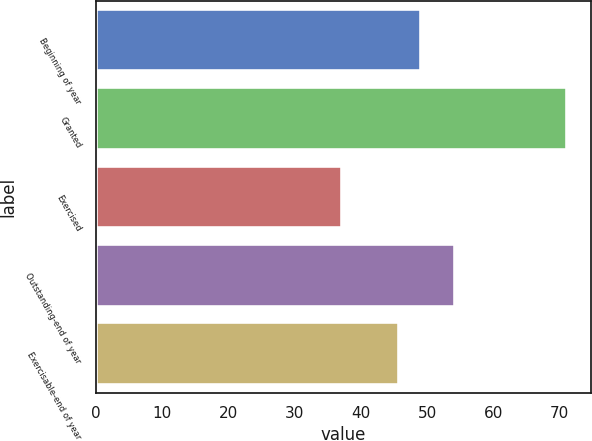Convert chart to OTSL. <chart><loc_0><loc_0><loc_500><loc_500><bar_chart><fcel>Beginning of year<fcel>Granted<fcel>Exercised<fcel>Outstanding-end of year<fcel>Exercisable-end of year<nl><fcel>49.1<fcel>71.12<fcel>37.19<fcel>54.17<fcel>45.71<nl></chart> 